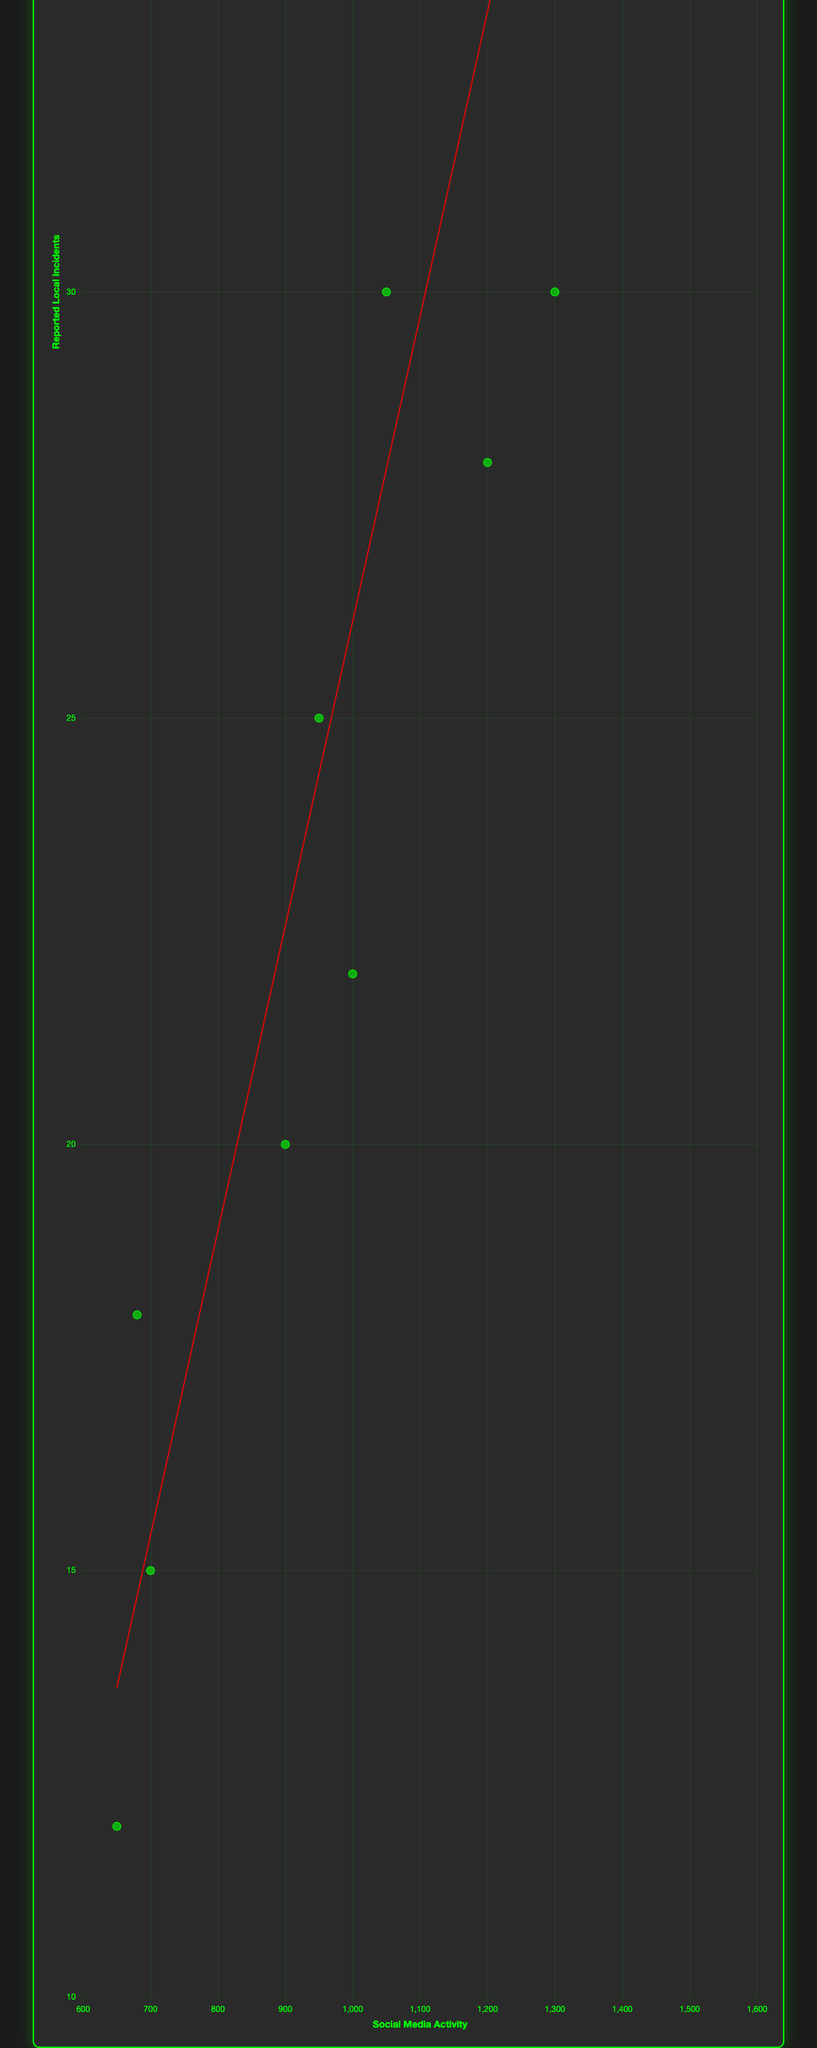What is the title of the plot? The title is located at the top of the plot. It reads "Social Media Activity vs. Reported Local Incidents".
Answer: Social Media Activity vs. Reported Local Incidents How many cities are represented in the scatter plot? Each city contributes three data points, one for each month. Counting the unique cities from the tooltip labels or legend would reveal the number.
Answer: 5 Which city has the most social media activity in January 2023? From data or by looking at the scatter points, find the point labeled with the highest x-value for January 2023.
Answer: New York What is the average reported local incidents for Chicago from January to March 2023? Sum the incidents for Chicago in January (20), February (25), and March (22), then divide by 3. (20+25+22)/3 = 67/3 ≈ 22.33
Answer: 22.33 Which city shows an increase in social media activity from January to March 2023? Track the trends in the social media activity data for each city across the months. New York, Los Angeles, Chicago, and Miami increase their activity.
Answer: New York, Los Angeles, Chicago, Miami Which month had the highest total reported local incidents across all cities? Sum the incidents for January (45+30+20+15+35=145), February (40+28+25+12+30=135), March (50+35+22+18+40=165). March has the highest total.
Answer: March How does the trend line relate to the overall data distribution? Observe that the trend line describes the overall linear relationship between social media activity and reported incidents, indicating a positive correlation. The trend line increases as social media activity increases.
Answer: Positive correlation Which city has the lowest reported local incidents in February 2023? Identify the point with the lowest y-value for February 2023 on the plot.
Answer: Houston Is there a city where the reported local incidents decrease while social media activity increases? Compare the trends of reported incidents and social media activity. Houston in February has decreased incidents but increased activity in March.
Answer: Houston 